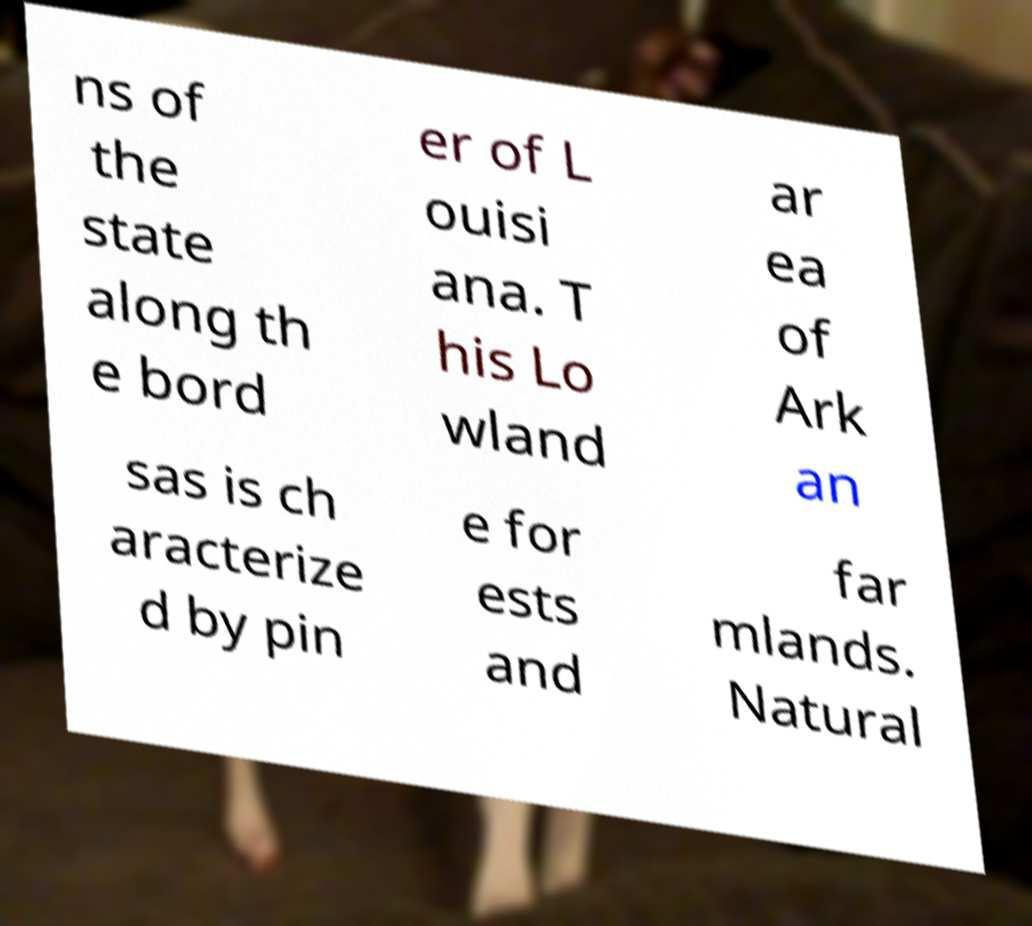Please read and relay the text visible in this image. What does it say? ns of the state along th e bord er of L ouisi ana. T his Lo wland ar ea of Ark an sas is ch aracterize d by pin e for ests and far mlands. Natural 